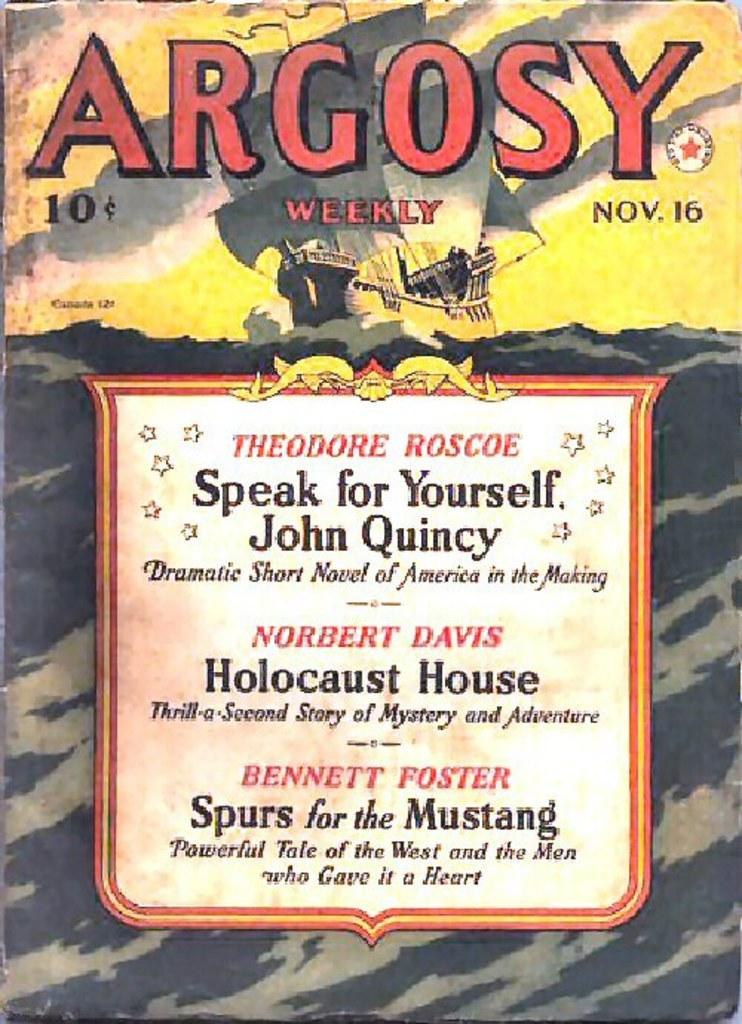<image>
Relay a brief, clear account of the picture shown. The cover of Argosy weekly with a sailing ship on it 